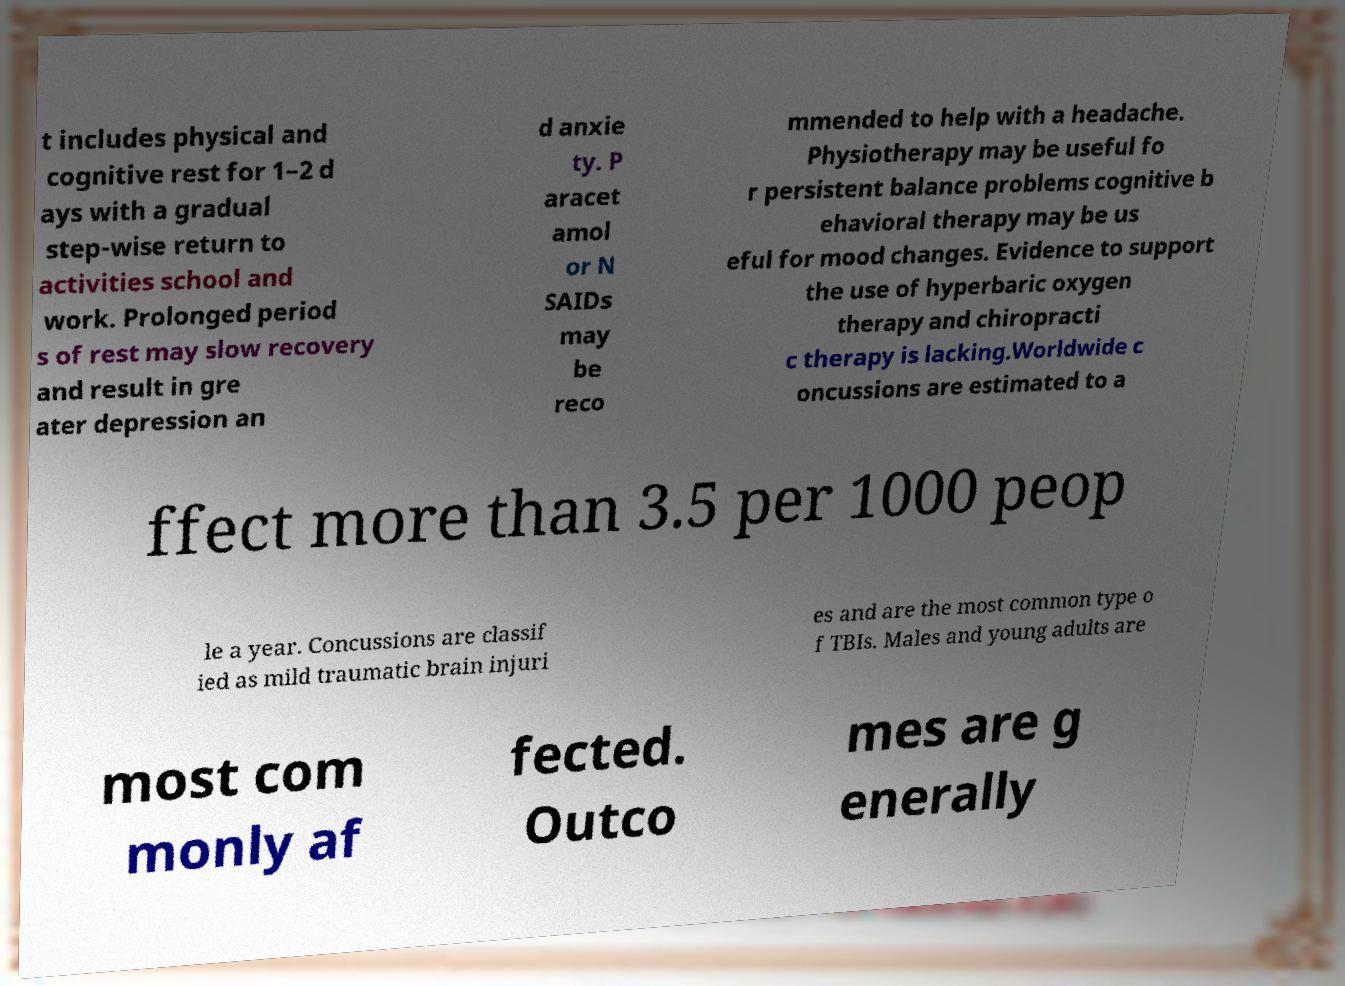There's text embedded in this image that I need extracted. Can you transcribe it verbatim? t includes physical and cognitive rest for 1–2 d ays with a gradual step-wise return to activities school and work. Prolonged period s of rest may slow recovery and result in gre ater depression an d anxie ty. P aracet amol or N SAIDs may be reco mmended to help with a headache. Physiotherapy may be useful fo r persistent balance problems cognitive b ehavioral therapy may be us eful for mood changes. Evidence to support the use of hyperbaric oxygen therapy and chiropracti c therapy is lacking.Worldwide c oncussions are estimated to a ffect more than 3.5 per 1000 peop le a year. Concussions are classif ied as mild traumatic brain injuri es and are the most common type o f TBIs. Males and young adults are most com monly af fected. Outco mes are g enerally 